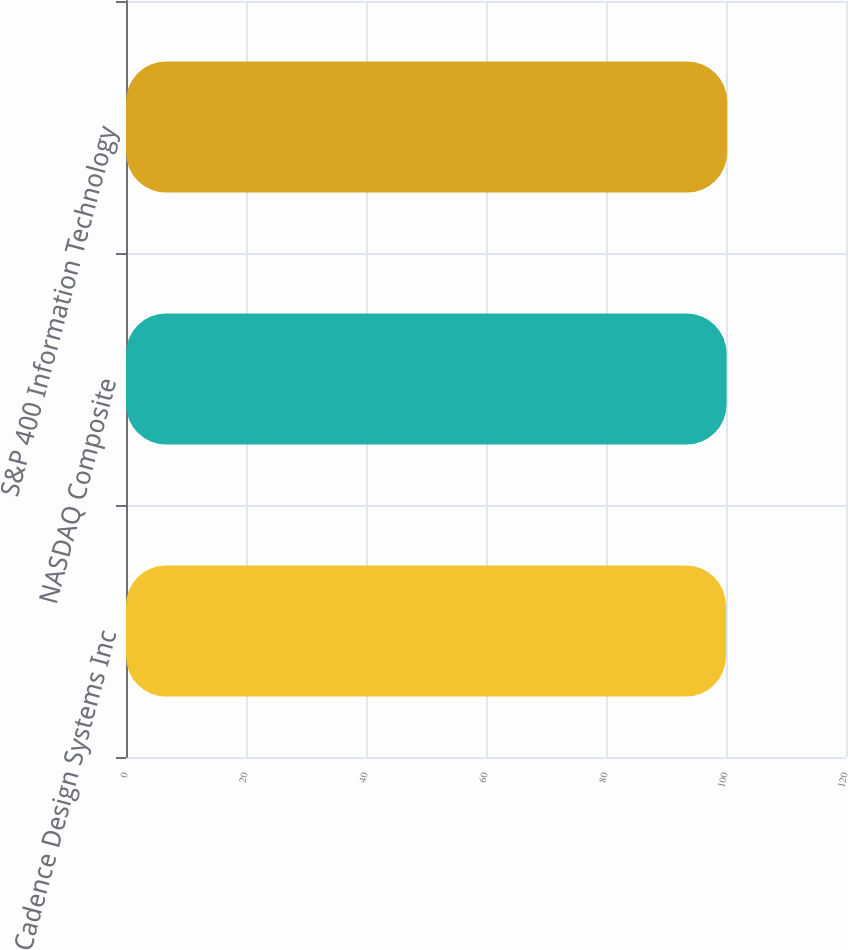<chart> <loc_0><loc_0><loc_500><loc_500><bar_chart><fcel>Cadence Design Systems Inc<fcel>NASDAQ Composite<fcel>S&P 400 Information Technology<nl><fcel>100<fcel>100.1<fcel>100.2<nl></chart> 